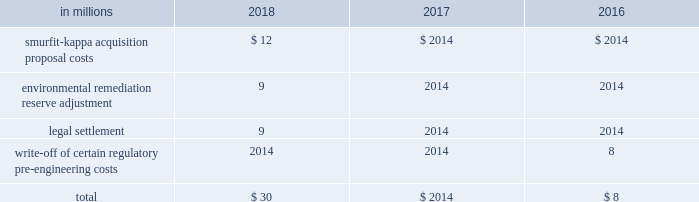Other corporate special items in addition , other pre-tax corporate special items totaling $ 30 million , $ 0 million and $ 8 million were recorded in 2018 , 2017 and 2016 , respectively .
Details of these charges were as follows : other corporate items .
Impairments of goodwill no goodwill impairment charges were recorded in 2018 , 2017 or 2016 .
Net losses on sales and impairments of businesses net losses on sales and impairments of businesses included in special items totaled a pre-tax loss of $ 122 million in 2018 related to the impairment of an intangible asset and fixed assets in the brazil packaging business , a pre-tax loss of $ 9 million in 2017 related to the write down of the long-lived assets of the company's asia foodservice business to fair value and a pre-tax loss of $ 70 million related to severance and the impairment of the ip asia packaging business in 2016 .
See note 8 divestitures and impairments on pages 54 and 55 of item 8 .
Financial statements and supplementary data for further discussion .
Description of business segments international paper 2019s business segments discussed below are consistent with the internal structure used to manage these businesses .
All segments are differentiated on a common product , common customer basis consistent with the business segmentation generally used in the forest products industry .
Industrial packaging international paper is the largest manufacturer of containerboard in the united states .
Our u.s .
Production capacity is over 13 million tons annually .
Our products include linerboard , medium , whitetop , recycled linerboard , recycled medium and saturating kraft .
About 80% ( 80 % ) of our production is converted into corrugated boxes and other packaging by our 179 north american container plants .
Additionally , we recycle approximately one million tons of occ and mixed and white paper through our 18 recycling plants .
Our container plants are supported by regional design centers , which offer total packaging solutions and supply chain initiatives .
In emea , our operations include one recycled fiber containerboard mill in morocco , a recycled containerboard mill in spain and 26 container plants in france , italy , spain , morocco and turkey .
In brazil , our operations include three containerboard mills and four box plants .
International paper also produces high quality coated paperboard for a variety of packaging end uses with 428000 tons of annual capacity at our mills in poland and russia .
Global cellulose fibers our cellulose fibers product portfolio includes fluff , market and specialty pulps .
International paper is the largest producer of fluff pulp which is used to make absorbent hygiene products like baby diapers , feminine care , adult incontinence and other non-woven products .
Our market pulp is used for tissue and paper products .
We continue to invest in exploring new innovative uses for our products , such as our specialty pulps , which are used for non-absorbent end uses including textiles , filtration , construction material , paints and coatings , reinforced plastics and more .
Our products are made in the united states , canada , france , poland , and russia and are sold around the world .
International paper facilities have annual dried pulp capacity of about 4 million metric tons .
Printing papers international paper is one of the world 2019s largest producers of printing and writing papers .
The primary product in this segment is uncoated papers .
This business produces papers for use in copiers , desktop and laser printers and digital imaging .
End-use applications include advertising and promotional materials such as brochures , pamphlets , greeting cards , books , annual reports and direct mail .
Uncoated papers also produces a variety of grades that are converted by our customers into envelopes , tablets , business forms and file folders .
Uncoated papers are sold under private label and international paper brand names that include hammermill , springhill , williamsburg , postmark , accent , great white , chamex , ballet , rey , pol , and svetocopy .
The mills producing uncoated papers are located in the united states , france , poland , russia , brazil and india .
The mills have uncoated paper production capacity of over 4 million tons annually .
Brazilian operations function through international paper do brasil , ltda , which owns or manages approximately 329000 acres of forestlands in brazil. .
What is the percentage of smurfit-kappa acquisition proposal costs among the total other corporate special items in addition in 2018? 
Rationale: it is the smurfit-kappa acquisition proposal costs divided by the total then turned into a percentage .
Computations: (12 / 30)
Answer: 0.4. 